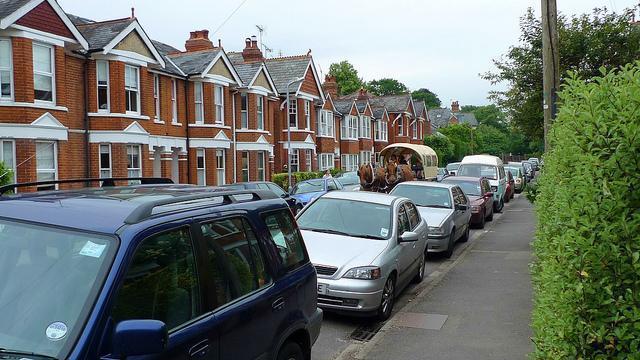Which conveyance pictured here uses less gas?
Indicate the correct choice and explain in the format: 'Answer: answer
Rationale: rationale.'
Options: Truck, van, buggy, car. Answer: buggy.
Rationale: The buggy in the middle of the road uses less gas than all of the cars parked on the street. 